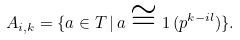<formula> <loc_0><loc_0><loc_500><loc_500>A _ { i , k } = \{ a \in T \, | \, a \cong 1 \, ( p ^ { k - i l } ) \} .</formula> 